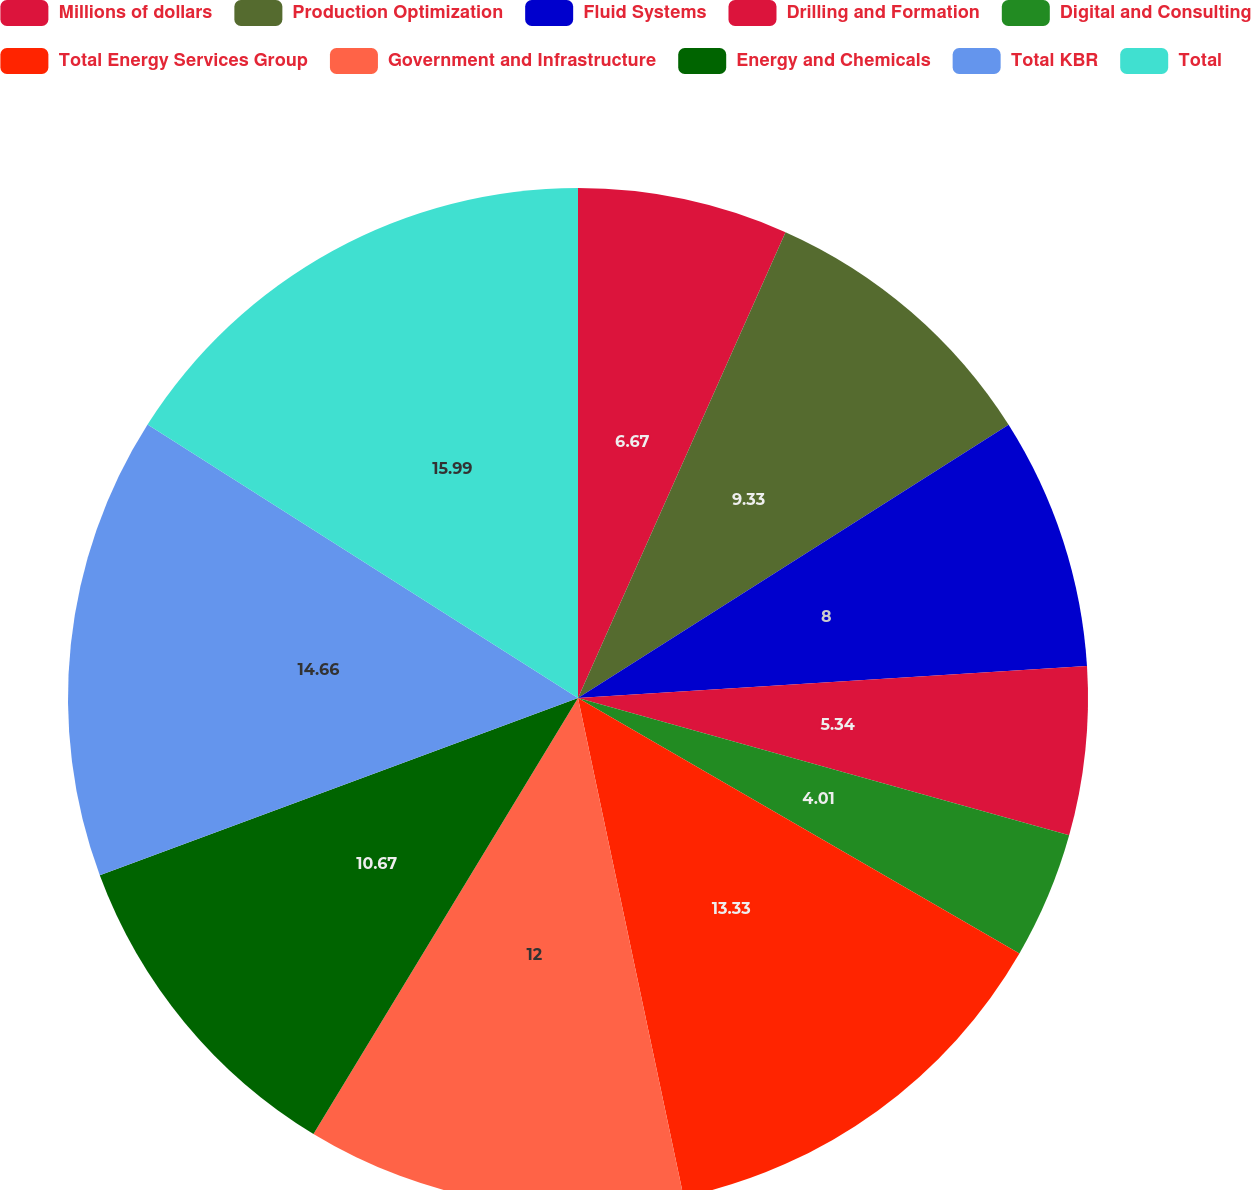<chart> <loc_0><loc_0><loc_500><loc_500><pie_chart><fcel>Millions of dollars<fcel>Production Optimization<fcel>Fluid Systems<fcel>Drilling and Formation<fcel>Digital and Consulting<fcel>Total Energy Services Group<fcel>Government and Infrastructure<fcel>Energy and Chemicals<fcel>Total KBR<fcel>Total<nl><fcel>6.67%<fcel>9.33%<fcel>8.0%<fcel>5.34%<fcel>4.01%<fcel>13.33%<fcel>12.0%<fcel>10.67%<fcel>14.66%<fcel>15.99%<nl></chart> 